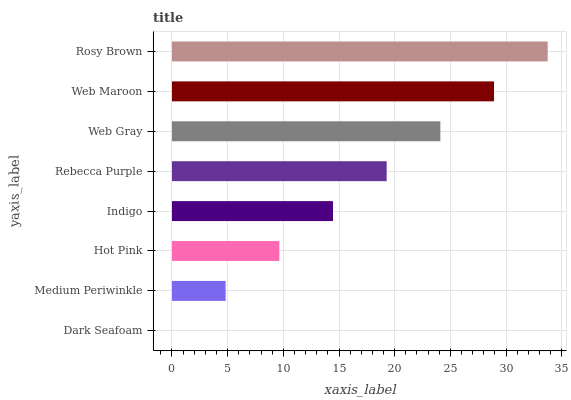Is Dark Seafoam the minimum?
Answer yes or no. Yes. Is Rosy Brown the maximum?
Answer yes or no. Yes. Is Medium Periwinkle the minimum?
Answer yes or no. No. Is Medium Periwinkle the maximum?
Answer yes or no. No. Is Medium Periwinkle greater than Dark Seafoam?
Answer yes or no. Yes. Is Dark Seafoam less than Medium Periwinkle?
Answer yes or no. Yes. Is Dark Seafoam greater than Medium Periwinkle?
Answer yes or no. No. Is Medium Periwinkle less than Dark Seafoam?
Answer yes or no. No. Is Rebecca Purple the high median?
Answer yes or no. Yes. Is Indigo the low median?
Answer yes or no. Yes. Is Medium Periwinkle the high median?
Answer yes or no. No. Is Medium Periwinkle the low median?
Answer yes or no. No. 